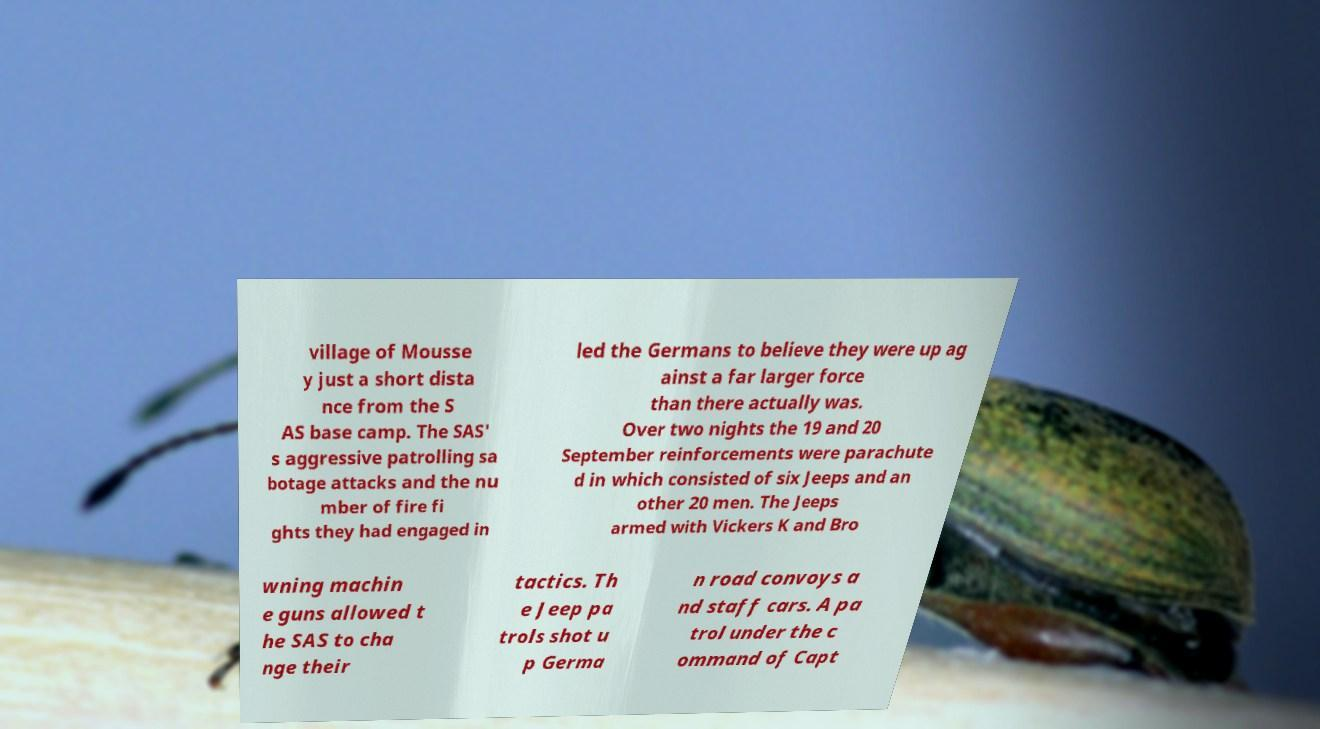There's text embedded in this image that I need extracted. Can you transcribe it verbatim? village of Mousse y just a short dista nce from the S AS base camp. The SAS' s aggressive patrolling sa botage attacks and the nu mber of fire fi ghts they had engaged in led the Germans to believe they were up ag ainst a far larger force than there actually was. Over two nights the 19 and 20 September reinforcements were parachute d in which consisted of six Jeeps and an other 20 men. The Jeeps armed with Vickers K and Bro wning machin e guns allowed t he SAS to cha nge their tactics. Th e Jeep pa trols shot u p Germa n road convoys a nd staff cars. A pa trol under the c ommand of Capt 